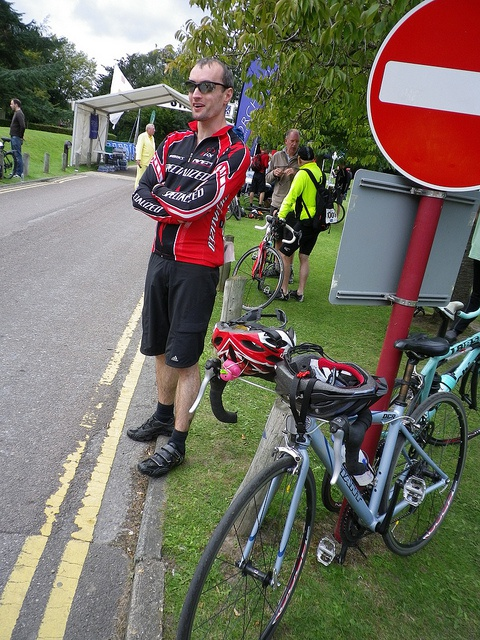Describe the objects in this image and their specific colors. I can see bicycle in black, gray, and darkgreen tones, people in black, gray, and brown tones, stop sign in black, brown, and lightgray tones, people in black, lime, gray, and darkgreen tones, and bicycle in black, gray, darkgreen, and lightblue tones in this image. 